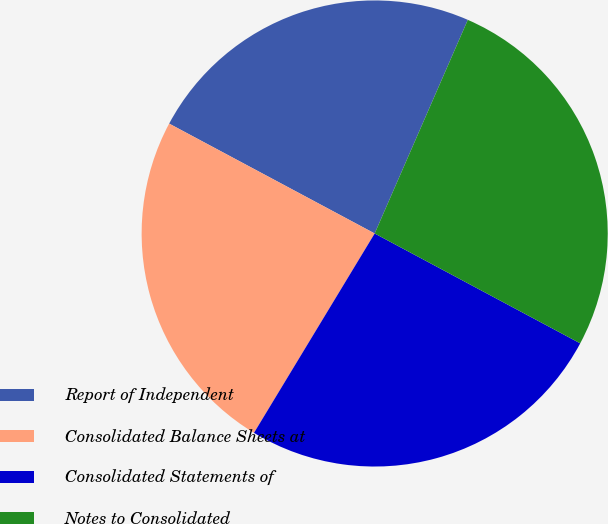Convert chart to OTSL. <chart><loc_0><loc_0><loc_500><loc_500><pie_chart><fcel>Report of Independent<fcel>Consolidated Balance Sheets at<fcel>Consolidated Statements of<fcel>Notes to Consolidated<nl><fcel>23.73%<fcel>24.15%<fcel>25.85%<fcel>26.27%<nl></chart> 